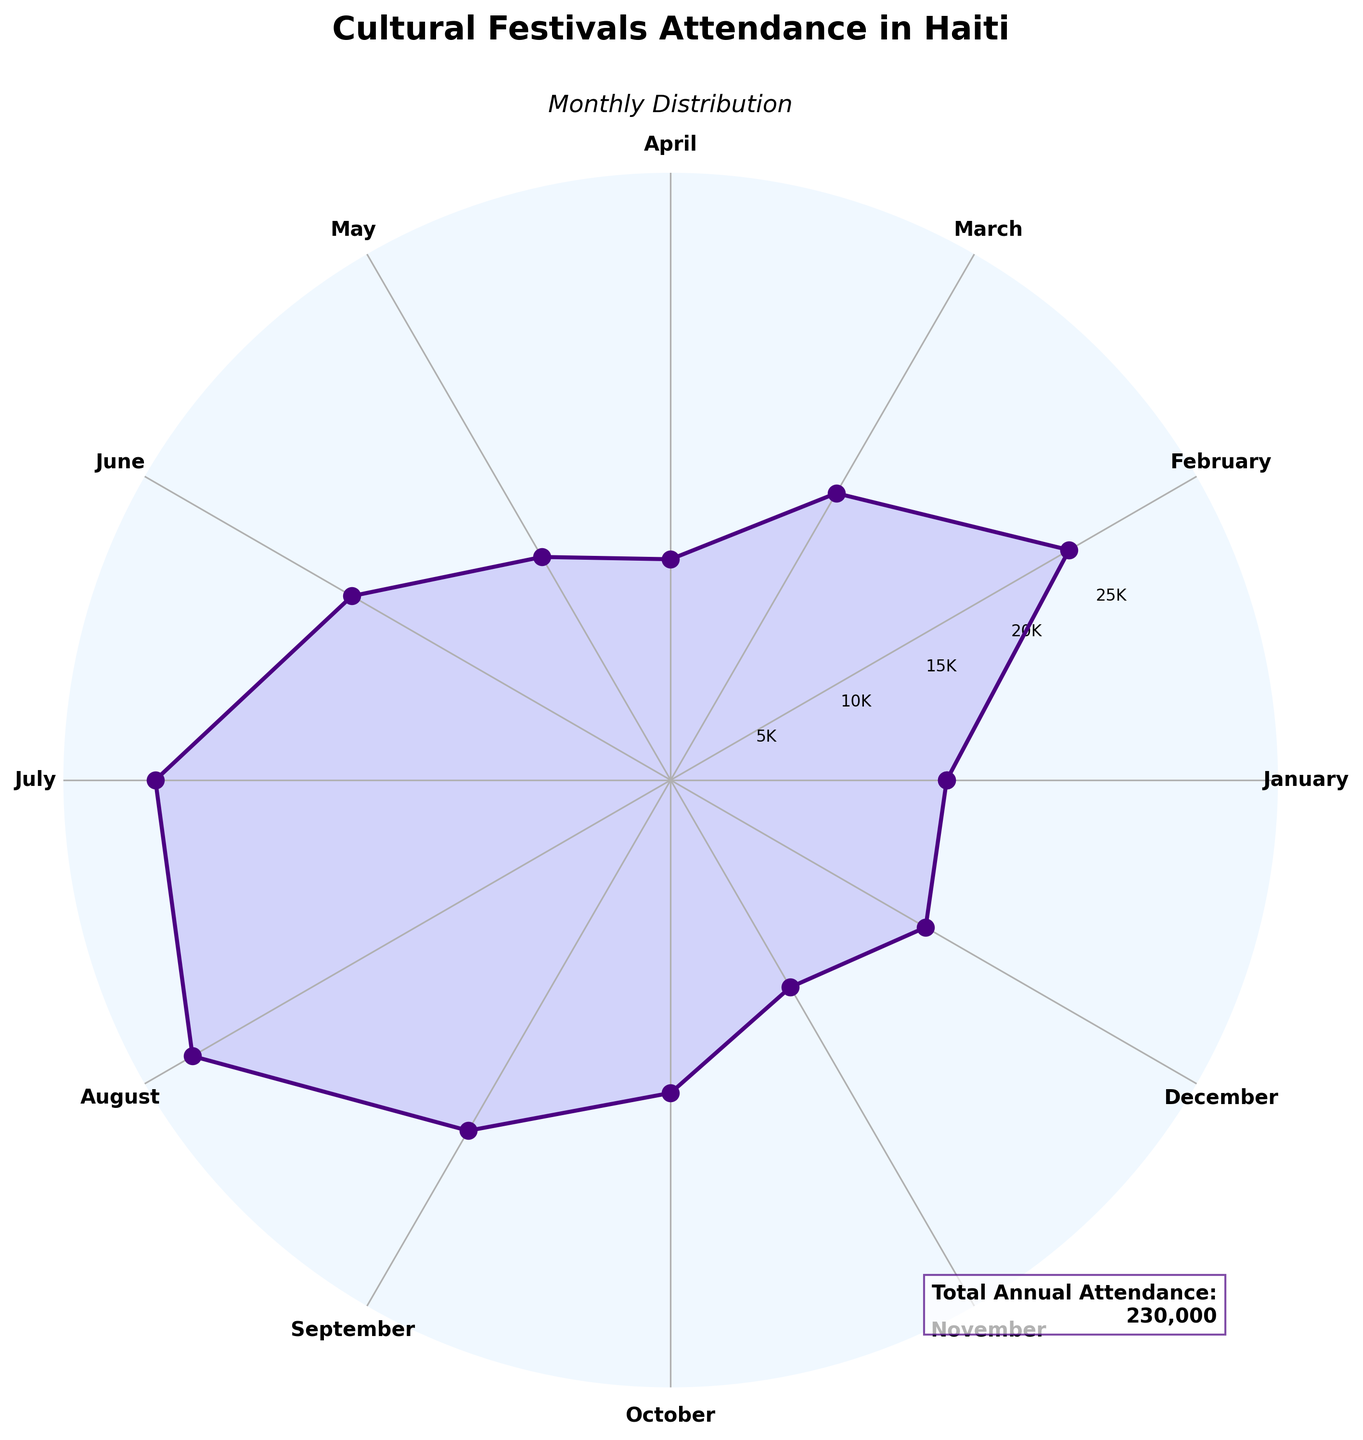What is the title of the figure? The title is usually located at the top of the figure and serves as a brief description of what the figure is about. From the visual inspection of the polar area chart, the title is "Cultural Festivals Attendance in Haiti".
Answer: Cultural Festivals Attendance in Haiti Which month has the highest festival attendance? To determine which month has the highest attendance, look for the longest radial line in the polar area chart. The longest line corresponds to August.
Answer: August What is the attendance number for the month with the lowest festival attendance? Find the shortest radial line on the chart. According to the data, April has the lowest attendance. The numeric value can be seen as the radial distance.
Answer: 12,000 Which months have an attendance of more than 20,000? Identify the radial lines extending beyond the 20,000 mark on the chart. These months are February, July, August, and September.
Answer: February, July, August, September How much is the total annual attendance? Look for any additional information on the figure that might summarize the data. There's a legend-like text that specifies "Total Annual Attendance: 230,000".
Answer: 230,000 What is the average festival attendance over the year? Calculate the average by dividing the total annual attendance by 12 (number of months). The total annual attendance is 230,000, so the average is 230,000 / 12.
Answer: 19,167 Which month has a higher attendance, June or December? Compare the radial lengths for June and December. The radial length for June is longer than for December, indicating June has a higher attendance.
Answer: June How many months have an attendance of fewer than 15,000? Look for radial lines that are shorter than the distance marked for 15,000. According to the chart, January, April, May, October, and November have fewer than 15,000 attendees. Count these months.
Answer: 5 By how much does attendance in July exceed that in January? Subtract the attendance in January from that in July to find the difference. July has 28,000 and January has 15,000. So, 28,000 - 15,000 = 13,000.
Answer: 13,000 